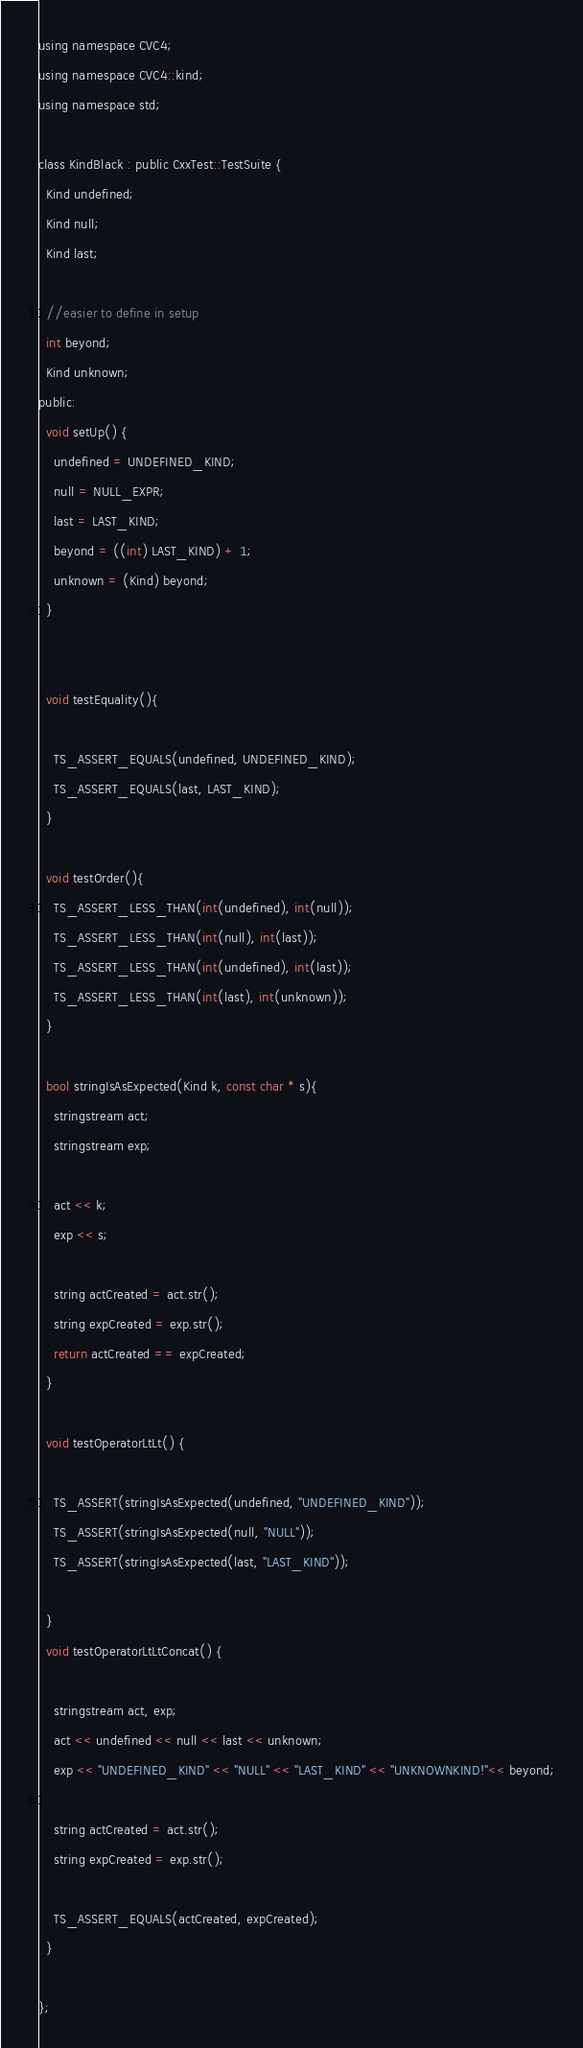<code> <loc_0><loc_0><loc_500><loc_500><_C_>using namespace CVC4;
using namespace CVC4::kind;
using namespace std;

class KindBlack : public CxxTest::TestSuite {
  Kind undefined;
  Kind null;
  Kind last;
  
  //easier to define in setup
  int beyond;
  Kind unknown;
public:
  void setUp() {
    undefined = UNDEFINED_KIND;
    null = NULL_EXPR;
    last = LAST_KIND;
    beyond = ((int) LAST_KIND) + 1;
    unknown = (Kind) beyond;
  }

  
  void testEquality(){

    TS_ASSERT_EQUALS(undefined, UNDEFINED_KIND);
    TS_ASSERT_EQUALS(last, LAST_KIND);
  }
  
  void testOrder(){
    TS_ASSERT_LESS_THAN(int(undefined), int(null));
    TS_ASSERT_LESS_THAN(int(null), int(last));
    TS_ASSERT_LESS_THAN(int(undefined), int(last));
    TS_ASSERT_LESS_THAN(int(last), int(unknown));
  }

  bool stringIsAsExpected(Kind k, const char * s){
    stringstream act;
    stringstream exp;

    act << k;
    exp << s;
    
    string actCreated = act.str();
    string expCreated = exp.str();
    return actCreated == expCreated;
  }

  void testOperatorLtLt() {

    TS_ASSERT(stringIsAsExpected(undefined, "UNDEFINED_KIND"));
    TS_ASSERT(stringIsAsExpected(null, "NULL"));
    TS_ASSERT(stringIsAsExpected(last, "LAST_KIND"));    

  }
  void testOperatorLtLtConcat() {

    stringstream act, exp;
    act << undefined << null << last << unknown;
    exp << "UNDEFINED_KIND" << "NULL" << "LAST_KIND" << "UNKNOWNKIND!"<< beyond;
    
    string actCreated = act.str();
    string expCreated = exp.str();
    
    TS_ASSERT_EQUALS(actCreated, expCreated);
  }

};
</code> 